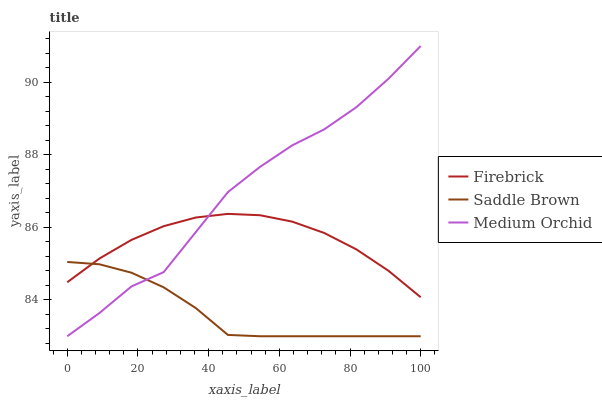Does Saddle Brown have the minimum area under the curve?
Answer yes or no. Yes. Does Medium Orchid have the maximum area under the curve?
Answer yes or no. Yes. Does Medium Orchid have the minimum area under the curve?
Answer yes or no. No. Does Saddle Brown have the maximum area under the curve?
Answer yes or no. No. Is Firebrick the smoothest?
Answer yes or no. Yes. Is Medium Orchid the roughest?
Answer yes or no. Yes. Is Saddle Brown the smoothest?
Answer yes or no. No. Is Saddle Brown the roughest?
Answer yes or no. No. Does Medium Orchid have the highest value?
Answer yes or no. Yes. Does Saddle Brown have the highest value?
Answer yes or no. No. Does Saddle Brown intersect Firebrick?
Answer yes or no. Yes. Is Saddle Brown less than Firebrick?
Answer yes or no. No. Is Saddle Brown greater than Firebrick?
Answer yes or no. No. 